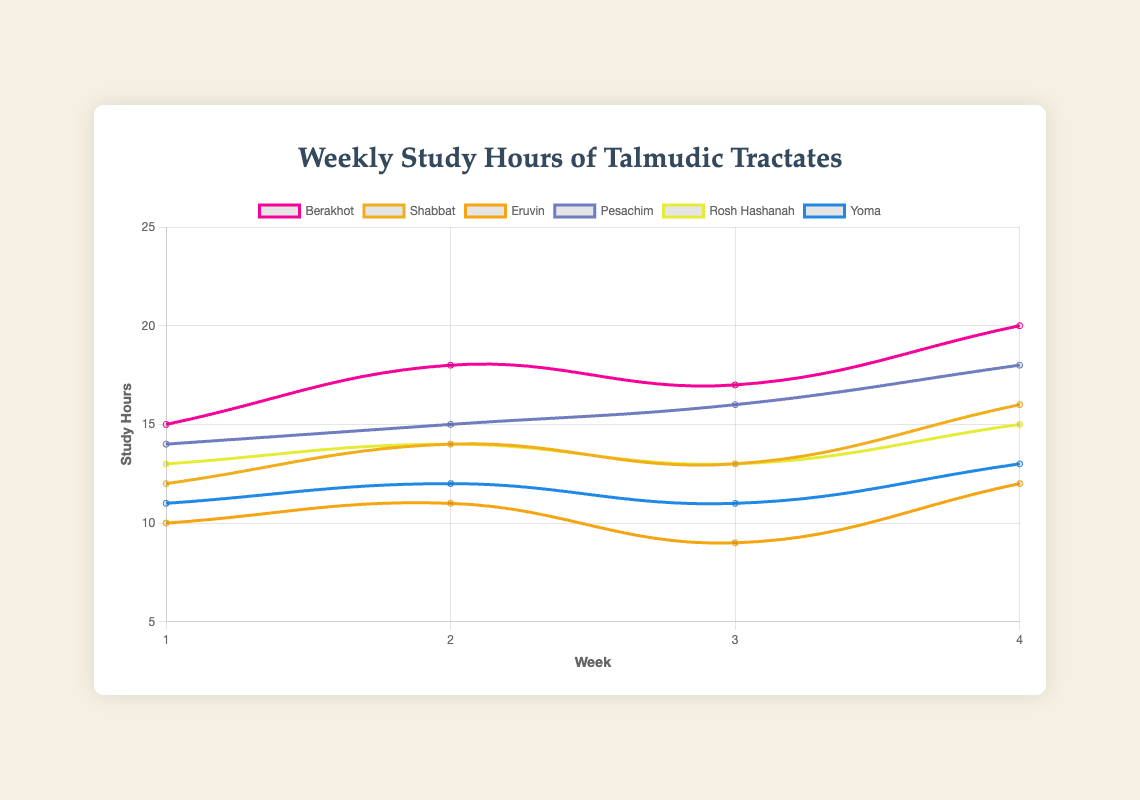How many hours did students spend studying the Berakhot tractate in total over the four weeks? To find the total study hours, sum the weekly hours for Berakhot: 15 (week 1) + 18 (week 2) + 17 (week 3) + 20 (week 4) = 70 hours.
Answer: 70 hours Which tractate had the highest study hours in week 4? Compare the study hours for each tractate in week 4: Berakhot (20), Shabbat (16), Eruvin (12), Pesachim (18), Rosh Hashanah (15), Yoma (13). The highest is Berakhot with 20 hours.
Answer: Berakhot On the visual chart, which tractate's line had the most consistent (least variable) study hours over the four weeks? Look for the tractate whose weekly study hours change the least. Eruvin’s study hours are 10, 11, 9, 12, which are relatively close together.
Answer: Eruvin In week 2, which tractate had more study hours: Shabbat or Yoma? Compare Shabbat and Yoma study hours in week 2: Shabbat (14) versus Yoma (12). Shabbat had more study hours.
Answer: Shabbat Which week showed the largest increase in study hours for Pesachim compared to the previous week? Calculate the increase in study hours for Pesachim each week: Week 2 (1-hour increase from 14 to 15), Week 3 (1-hour increase from 15 to 16), Week 4 (2-hour increase from 16 to 18). The largest increase is from week 3 to week 4.
Answer: Week 4 What are the average study hours per week for the Rosh Hashanah tractate? Calculate the average by summing Rosh Hashanah weekly hours (13 + 14 + 13 + 15 = 55) and divide by the number of weeks (55/4).
Answer: 13.75 hours Between weeks 1 and 4, which tractate showed the largest overall increase in study hours? Calculate the difference between week 4 and week 1 for all tractates: Berakhot (5 hours), Shabbat (4 hours), Eruvin (2 hours), Pesachim (4 hours), Rosh Hashanah (2 hours), Yoma (2 hours). The largest increase is with Berakhot (20 - 15 = 5 hours).
Answer: Berakhot Which tractate displayed a decrease in study hours in any of the weeks? Compare week-by-week study hours for decreases: Eruvin had a decrease from week 2 (11) to week 3 (9).
Answer: Eruvin 